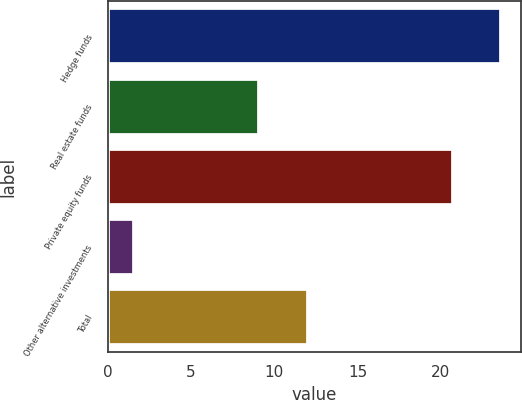Convert chart. <chart><loc_0><loc_0><loc_500><loc_500><bar_chart><fcel>Hedge funds<fcel>Real estate funds<fcel>Private equity funds<fcel>Other alternative investments<fcel>Total<nl><fcel>23.6<fcel>9.1<fcel>20.7<fcel>1.6<fcel>12<nl></chart> 